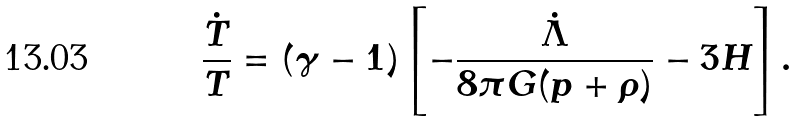Convert formula to latex. <formula><loc_0><loc_0><loc_500><loc_500>\frac { \dot { T } } { T } = ( \gamma - 1 ) \left [ - \frac { \dot { \Lambda } } { 8 \pi G ( p + \rho ) } - 3 H \right ] .</formula> 